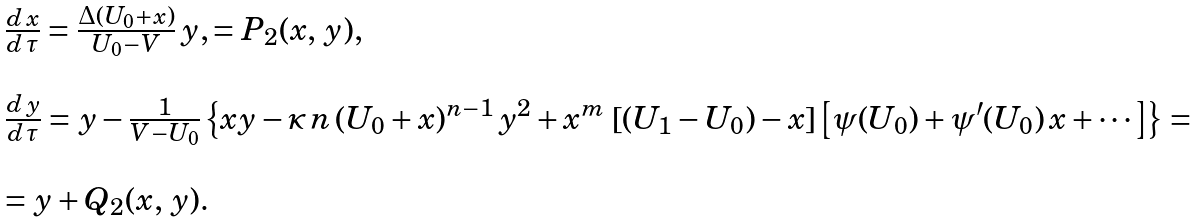Convert formula to latex. <formula><loc_0><loc_0><loc_500><loc_500>\begin{array} { l } \frac { d \, x } { d \, \tau } = \frac { \Delta ( U _ { 0 } + x ) } { U _ { 0 } - V } \, y , = P _ { 2 } ( x , \, y ) , \\ \\ \frac { d \, y } { d \, \tau } = y - \frac { 1 } { V - U _ { 0 } } \left \{ x y - \varkappa \, n \, ( U _ { 0 } + x ) ^ { n - 1 } \, y ^ { 2 } + x ^ { m } \, \left [ ( U _ { 1 } - U _ { 0 } ) - x \right ] \left [ \psi ( U _ { 0 } ) + \psi ^ { \prime } ( U _ { 0 } ) \, x + \cdots \right ] \right \} = \\ \\ = y + Q _ { 2 } ( x , \, y ) . \end{array}</formula> 